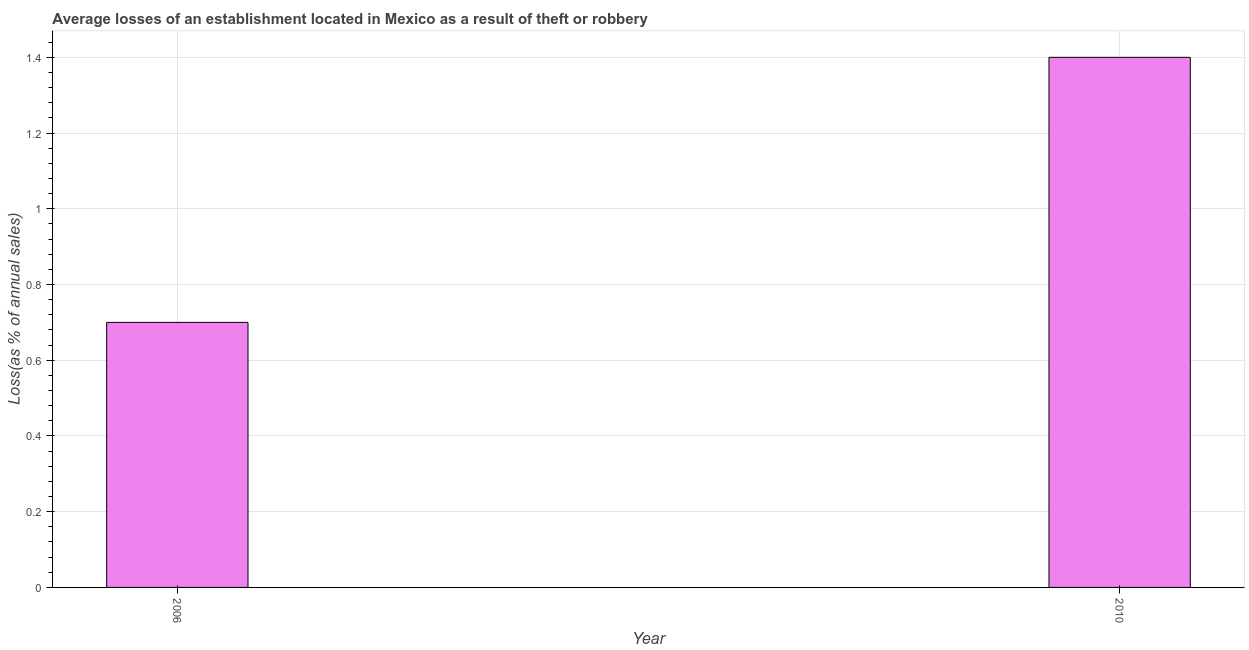Does the graph contain grids?
Your response must be concise. Yes. What is the title of the graph?
Make the answer very short. Average losses of an establishment located in Mexico as a result of theft or robbery. What is the label or title of the X-axis?
Ensure brevity in your answer.  Year. What is the label or title of the Y-axis?
Provide a succinct answer. Loss(as % of annual sales). Across all years, what is the minimum losses due to theft?
Offer a very short reply. 0.7. In which year was the losses due to theft maximum?
Offer a very short reply. 2010. In which year was the losses due to theft minimum?
Your answer should be very brief. 2006. What is the sum of the losses due to theft?
Keep it short and to the point. 2.1. What is the difference between the losses due to theft in 2006 and 2010?
Keep it short and to the point. -0.7. What is the average losses due to theft per year?
Your answer should be compact. 1.05. What is the median losses due to theft?
Offer a terse response. 1.05. Do a majority of the years between 2006 and 2010 (inclusive) have losses due to theft greater than 0.64 %?
Your answer should be very brief. Yes. Is the losses due to theft in 2006 less than that in 2010?
Provide a succinct answer. Yes. In how many years, is the losses due to theft greater than the average losses due to theft taken over all years?
Provide a short and direct response. 1. Are all the bars in the graph horizontal?
Your response must be concise. No. How many years are there in the graph?
Your answer should be compact. 2. What is the difference between two consecutive major ticks on the Y-axis?
Ensure brevity in your answer.  0.2. What is the Loss(as % of annual sales) of 2006?
Give a very brief answer. 0.7. What is the difference between the Loss(as % of annual sales) in 2006 and 2010?
Your answer should be compact. -0.7. 